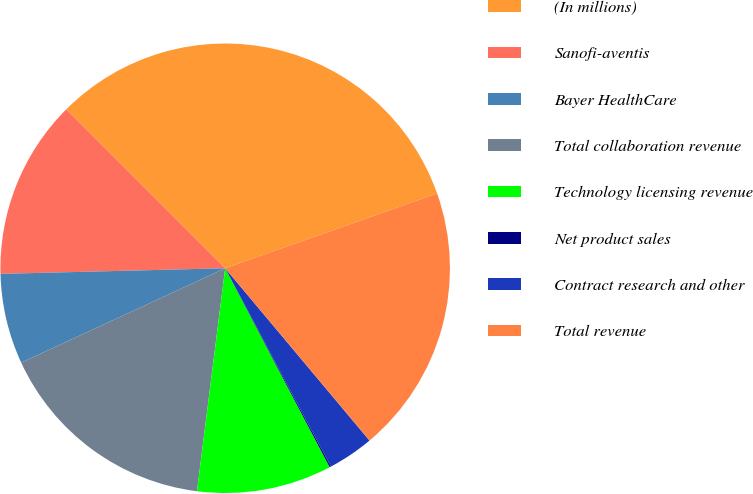Convert chart to OTSL. <chart><loc_0><loc_0><loc_500><loc_500><pie_chart><fcel>(In millions)<fcel>Sanofi-aventis<fcel>Bayer HealthCare<fcel>Total collaboration revenue<fcel>Technology licensing revenue<fcel>Net product sales<fcel>Contract research and other<fcel>Total revenue<nl><fcel>32.1%<fcel>12.9%<fcel>6.5%<fcel>16.1%<fcel>9.7%<fcel>0.1%<fcel>3.3%<fcel>19.3%<nl></chart> 